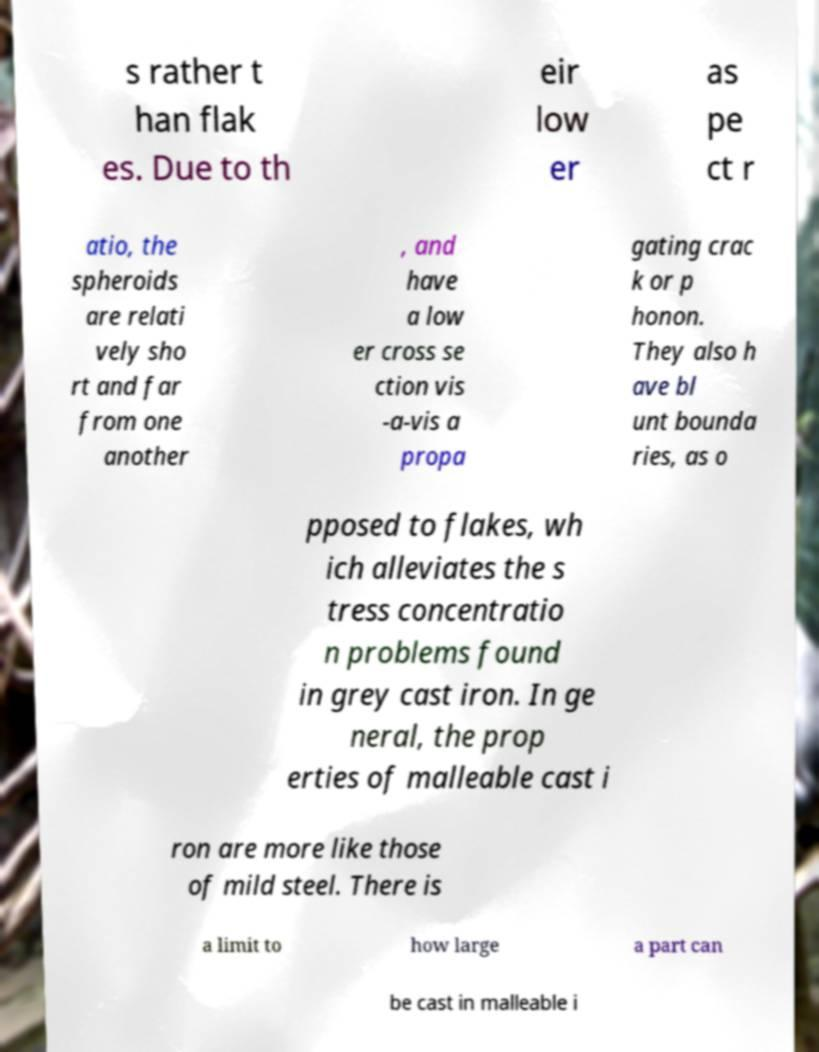Please read and relay the text visible in this image. What does it say? s rather t han flak es. Due to th eir low er as pe ct r atio, the spheroids are relati vely sho rt and far from one another , and have a low er cross se ction vis -a-vis a propa gating crac k or p honon. They also h ave bl unt bounda ries, as o pposed to flakes, wh ich alleviates the s tress concentratio n problems found in grey cast iron. In ge neral, the prop erties of malleable cast i ron are more like those of mild steel. There is a limit to how large a part can be cast in malleable i 